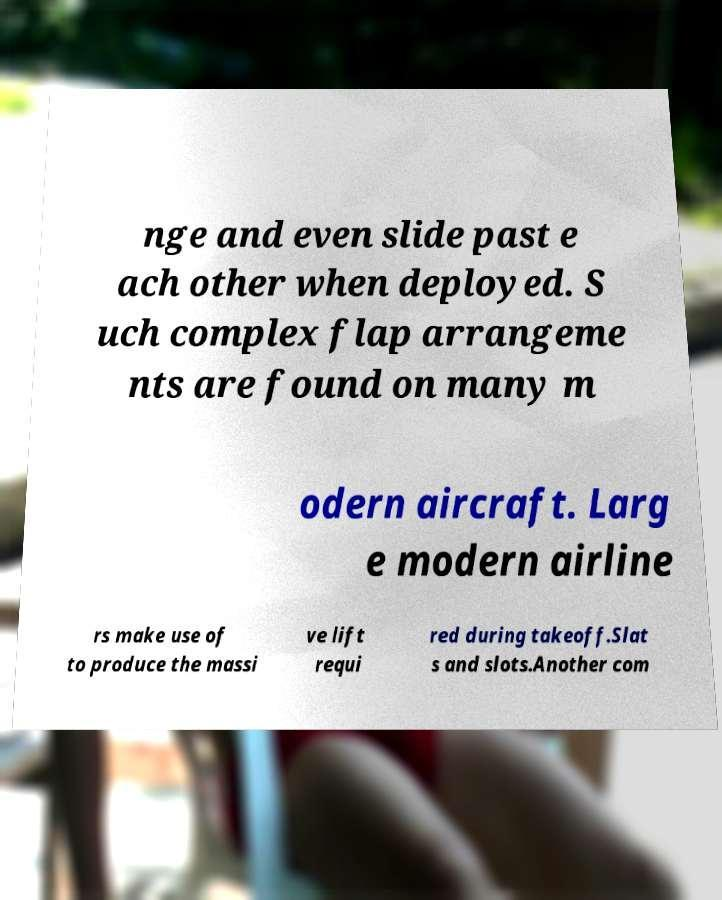Could you assist in decoding the text presented in this image and type it out clearly? nge and even slide past e ach other when deployed. S uch complex flap arrangeme nts are found on many m odern aircraft. Larg e modern airline rs make use of to produce the massi ve lift requi red during takeoff.Slat s and slots.Another com 